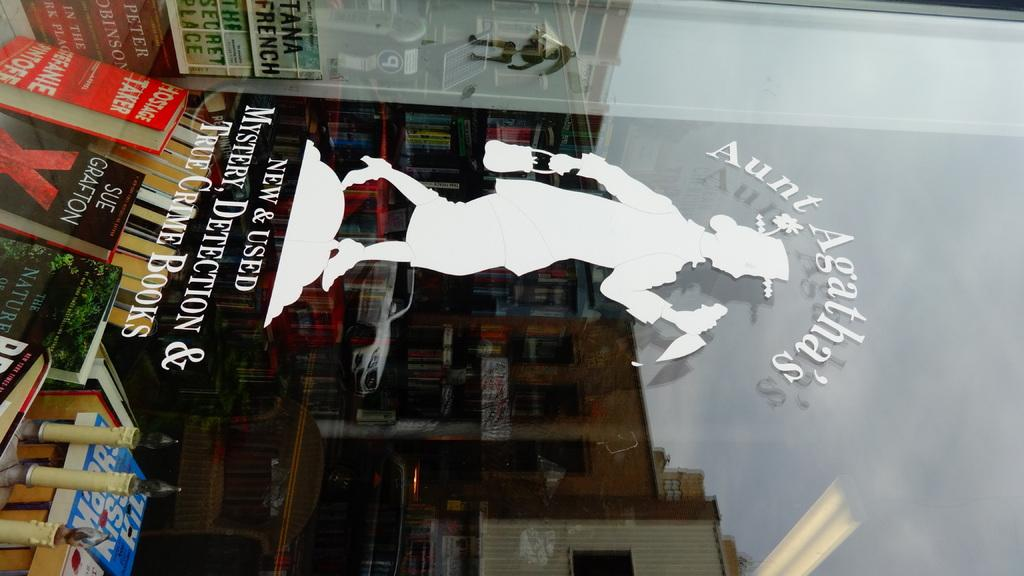What is the main object in the picture with text and an image? There is a glass with text and an image in the picture. What else can be seen in the picture besides the glass? There are books, buildings, vehicles, and the sky visible in the picture. Can you describe the buildings in the picture? The buildings in the picture are part of the background and provide context for the scene. What type of vehicles are present in the picture? The vehicles in the picture are not specified, but they could be cars, buses, or other forms of transportation. How many brothers are depicted in the picture? There are no brothers depicted in the picture; the focus is on the glass with text and an image, as well as the surrounding environment. 